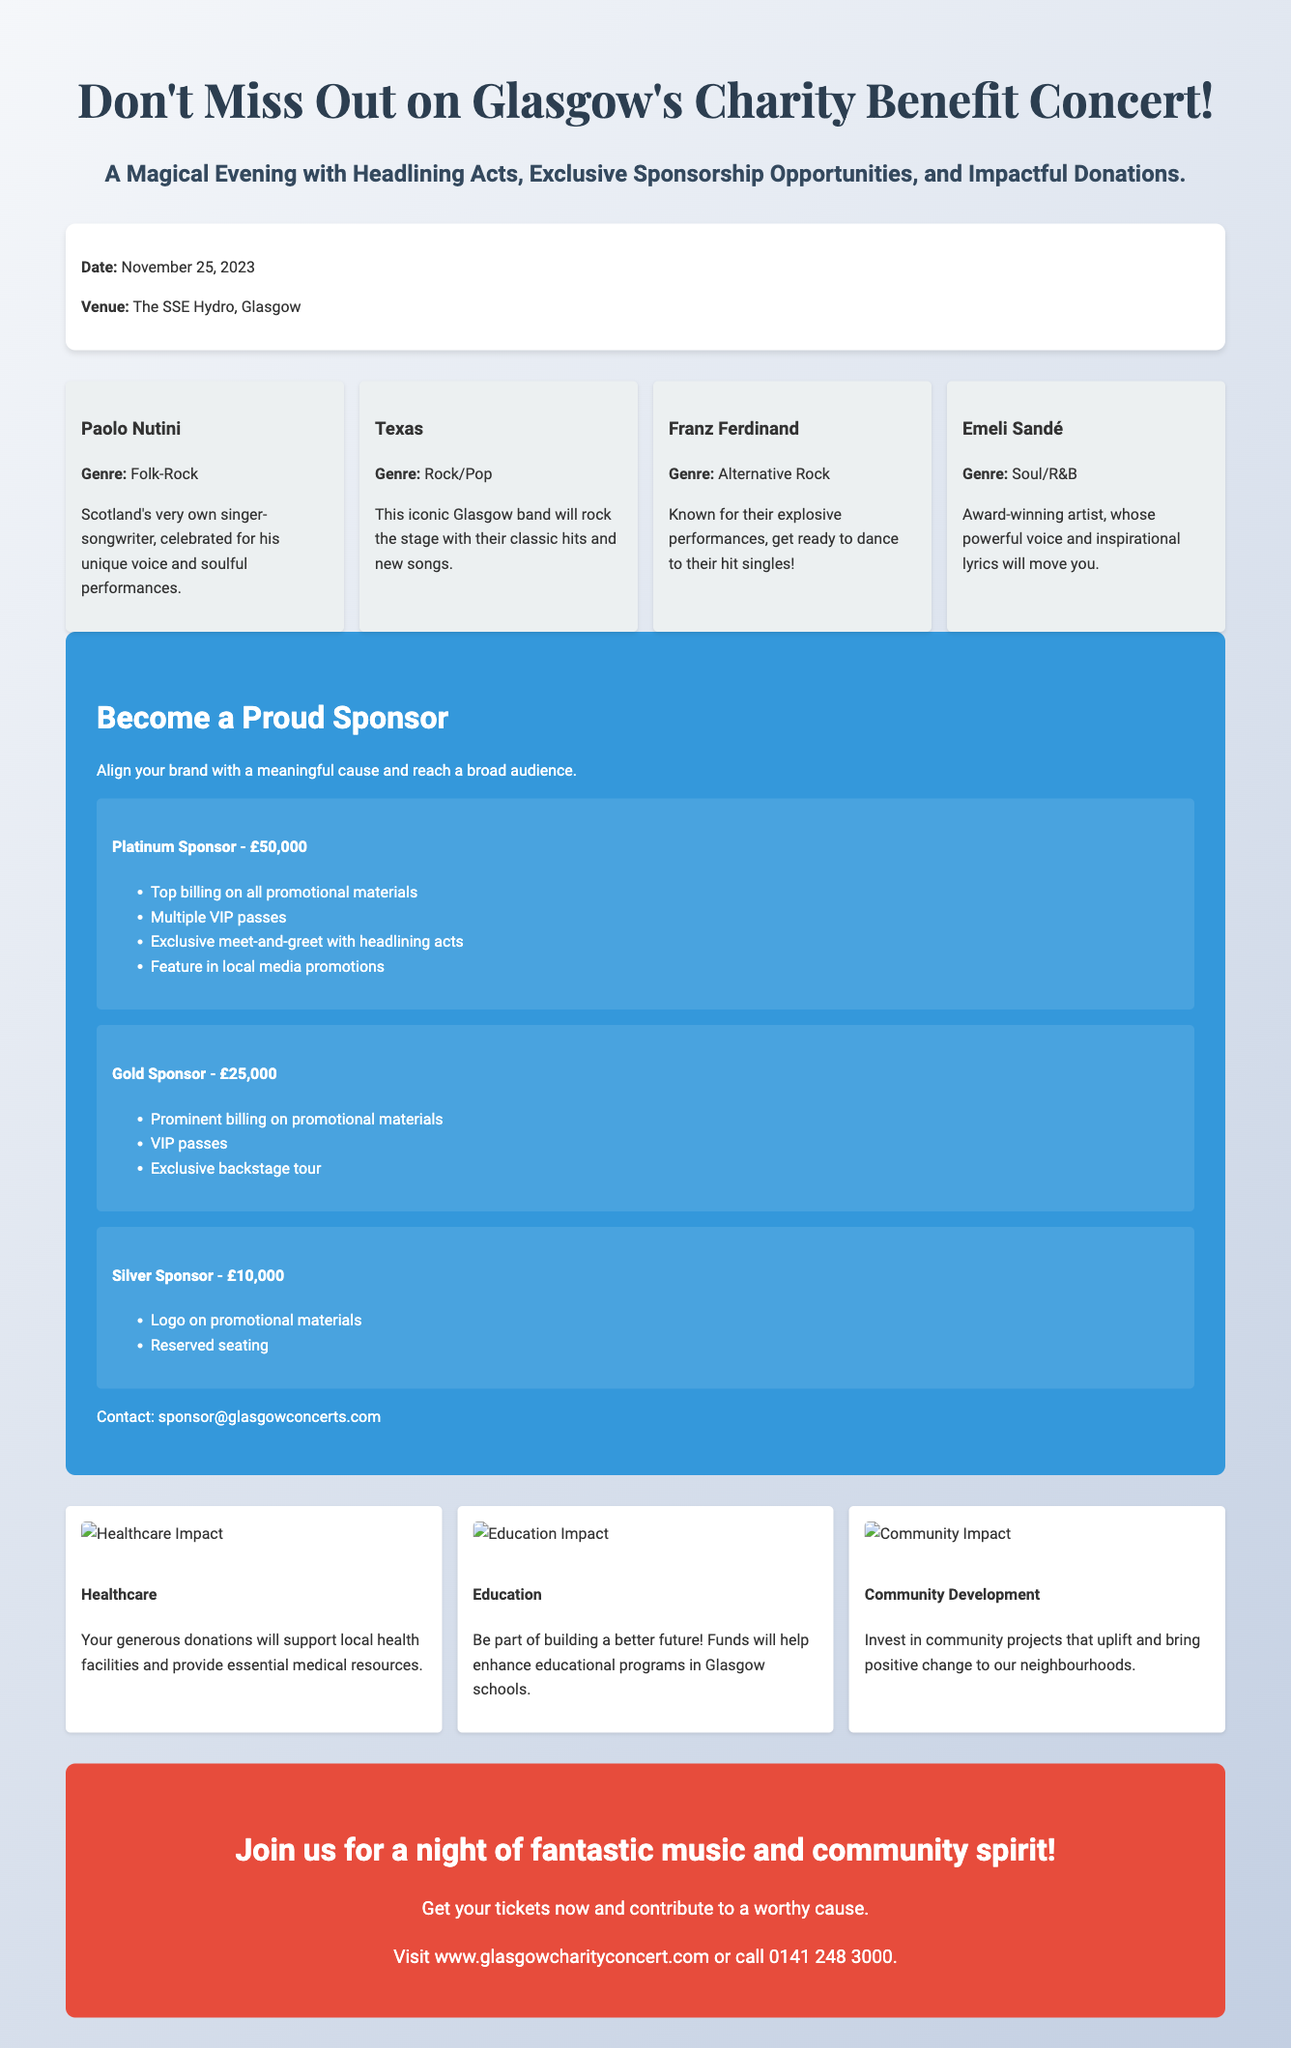What is the date of the concert? The date of the concert is explicitly stated in the document as November 25, 2023.
Answer: November 25, 2023 Who is headlining the concert alongside Paolo Nutini? The document lists Texas, Franz Ferdinand, and Emeli Sandé as additional headlining acts, making it necessary to identify them for this question.
Answer: Texas, Franz Ferdinand, Emeli Sandé What is the highest sponsorship tier? The document specifies the Platinum Sponsor as the highest sponsorship tier at £50,000.
Answer: Platinum Sponsor - £50,000 What will donations support in healthcare? The document highlights that donations will support local health facilities and provide essential medical resources, which is a critical point for understanding the donation impact.
Answer: Local health facilities How many VIP passes does a Gold Sponsor receive? The tier under Gold Sponsor mentions that VIP passes are included, and counting them gives this specific information.
Answer: VIP passes What genre is associated with Emeli Sandé? The document states that Emeli Sandé's genre is Soul/R&B, which directly answers the query about her musical classification.
Answer: Soul/R&B Which venue will host the concert? The venue for the concert is clearly indicated as The SSE Hydro, Glasgow.
Answer: The SSE Hydro, Glasgow What is the purpose of the event? The document describes that the concert is a Charity Benefit, indicating its primary objective of supporting a cause.
Answer: Charity Benefit 